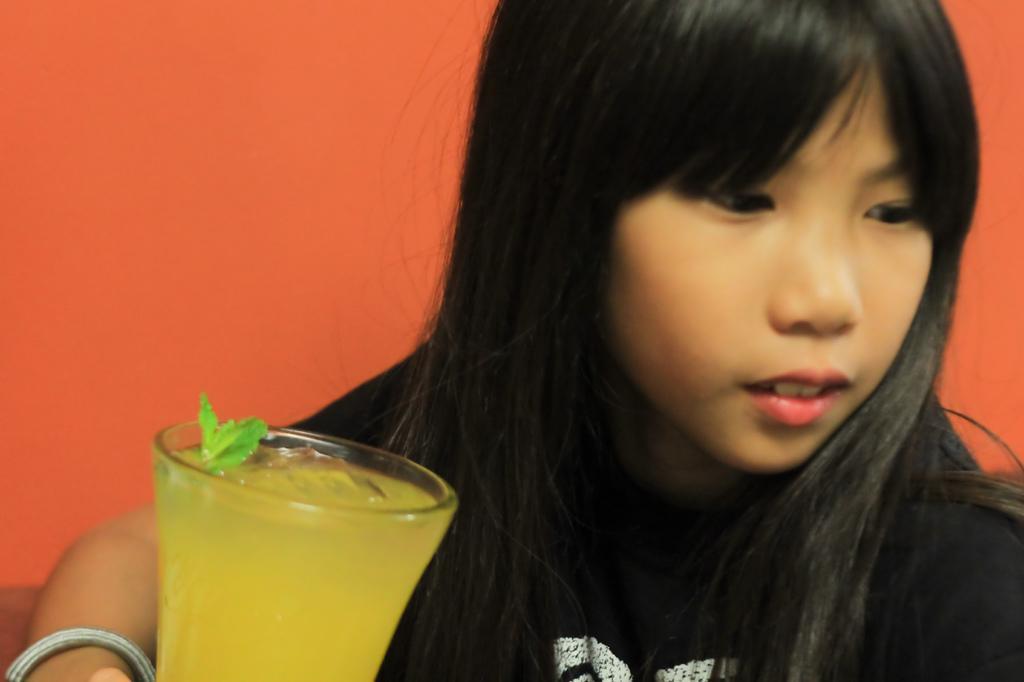Could you give a brief overview of what you see in this image? In this picture I can see a girl, there is a glass with liquid, and there is an orange color background. 